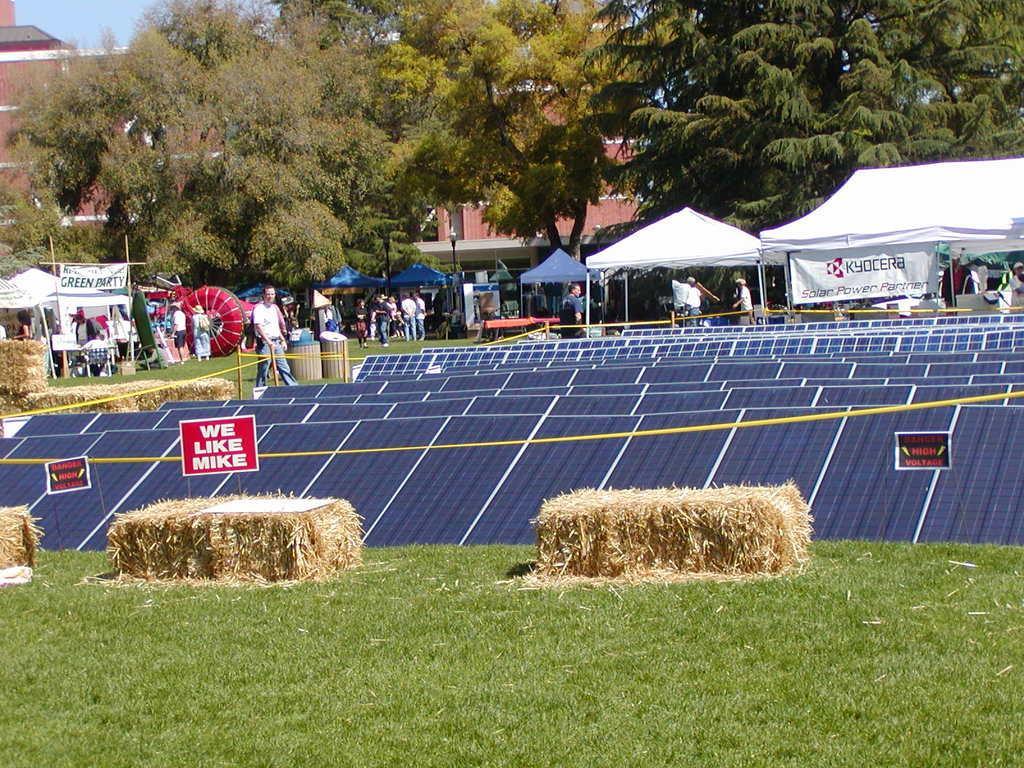Please provide a concise description of this image. In this picture we can see some grass on the ground. There are bunches of dry grass. We can see some solar panels on the grass. There are a few tents, posters, people and some objects are visible at the back. There are trees and a building is visible in the background. We can see the sky in the top left. 